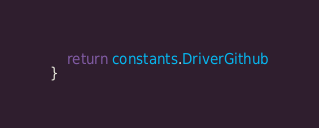<code> <loc_0><loc_0><loc_500><loc_500><_Go_>	return constants.DriverGithub
}
</code> 